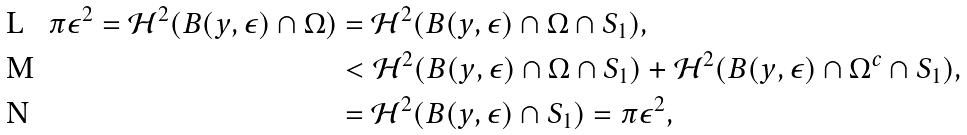Convert formula to latex. <formula><loc_0><loc_0><loc_500><loc_500>\pi \epsilon ^ { 2 } = \mathcal { H } ^ { 2 } ( B ( y , \epsilon ) \cap \Omega ) & = \mathcal { H } ^ { 2 } ( B ( y , \epsilon ) \cap \Omega \cap S _ { 1 } ) , \\ & < \mathcal { H } ^ { 2 } ( B ( y , \epsilon ) \cap \Omega \cap S _ { 1 } ) + \mathcal { H } ^ { 2 } ( B ( y , \epsilon ) \cap \Omega ^ { c } \cap S _ { 1 } ) , \\ & = \mathcal { H } ^ { 2 } ( B ( y , \epsilon ) \cap S _ { 1 } ) = \pi \epsilon ^ { 2 } ,</formula> 